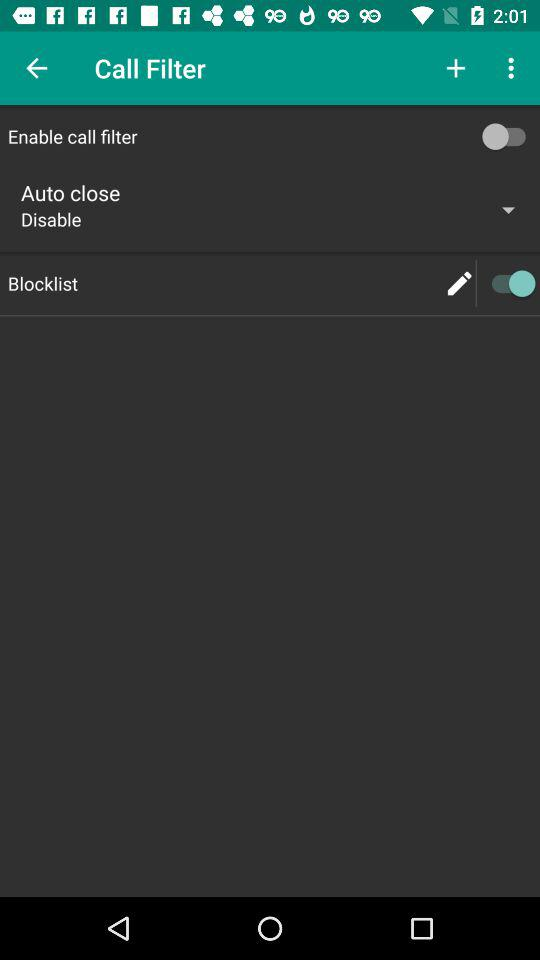How many items have a switch?
Answer the question using a single word or phrase. 2 